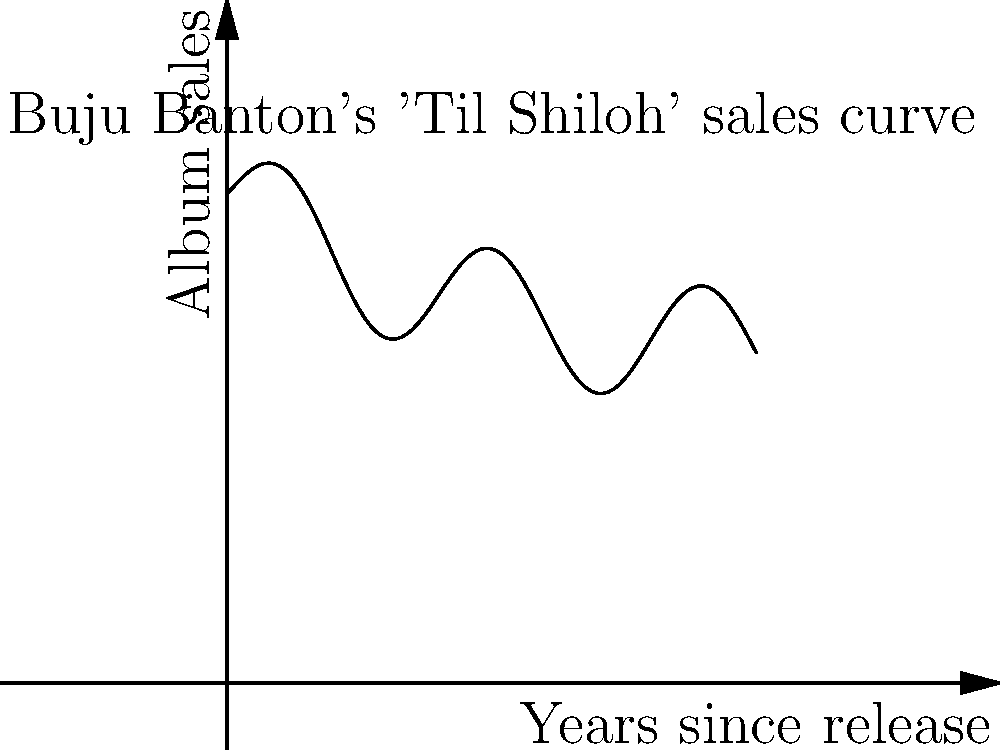The graph represents the sales of Buju Banton's iconic album "'Til Shiloh" over time. If the sales function is given by $S(t) = 50000 + 30000e^{-0.2t} + 10000\sin(\frac{\pi t}{2})$, where $t$ is the time in years since the album's release, at what point in time (to the nearest year) is the rate of change of album sales equal to zero? To find when the rate of change of album sales is zero, we need to follow these steps:

1) The rate of change is given by the derivative of the sales function. Let's calculate $S'(t)$:

   $S'(t) = -6000e^{-0.2t} + 5000\pi\cos(\frac{\pi t}{2})$

2) We want to find when $S'(t) = 0$:

   $-6000e^{-0.2t} + 5000\pi\cos(\frac{\pi t}{2}) = 0$

3) This equation is transcendental and cannot be solved algebraically. We need to use numerical methods or graphing to find the solution.

4) By graphing or using a numerical solver, we find that the first positive solution occurs at approximately $t \approx 3.14$ years.

5) Rounding to the nearest year, we get 3 years.

This means that after about 3 years, the album's sales rate momentarily stops decreasing and starts increasing again, possibly due to a resurgence in popularity or a special anniversary edition release.
Answer: 3 years 